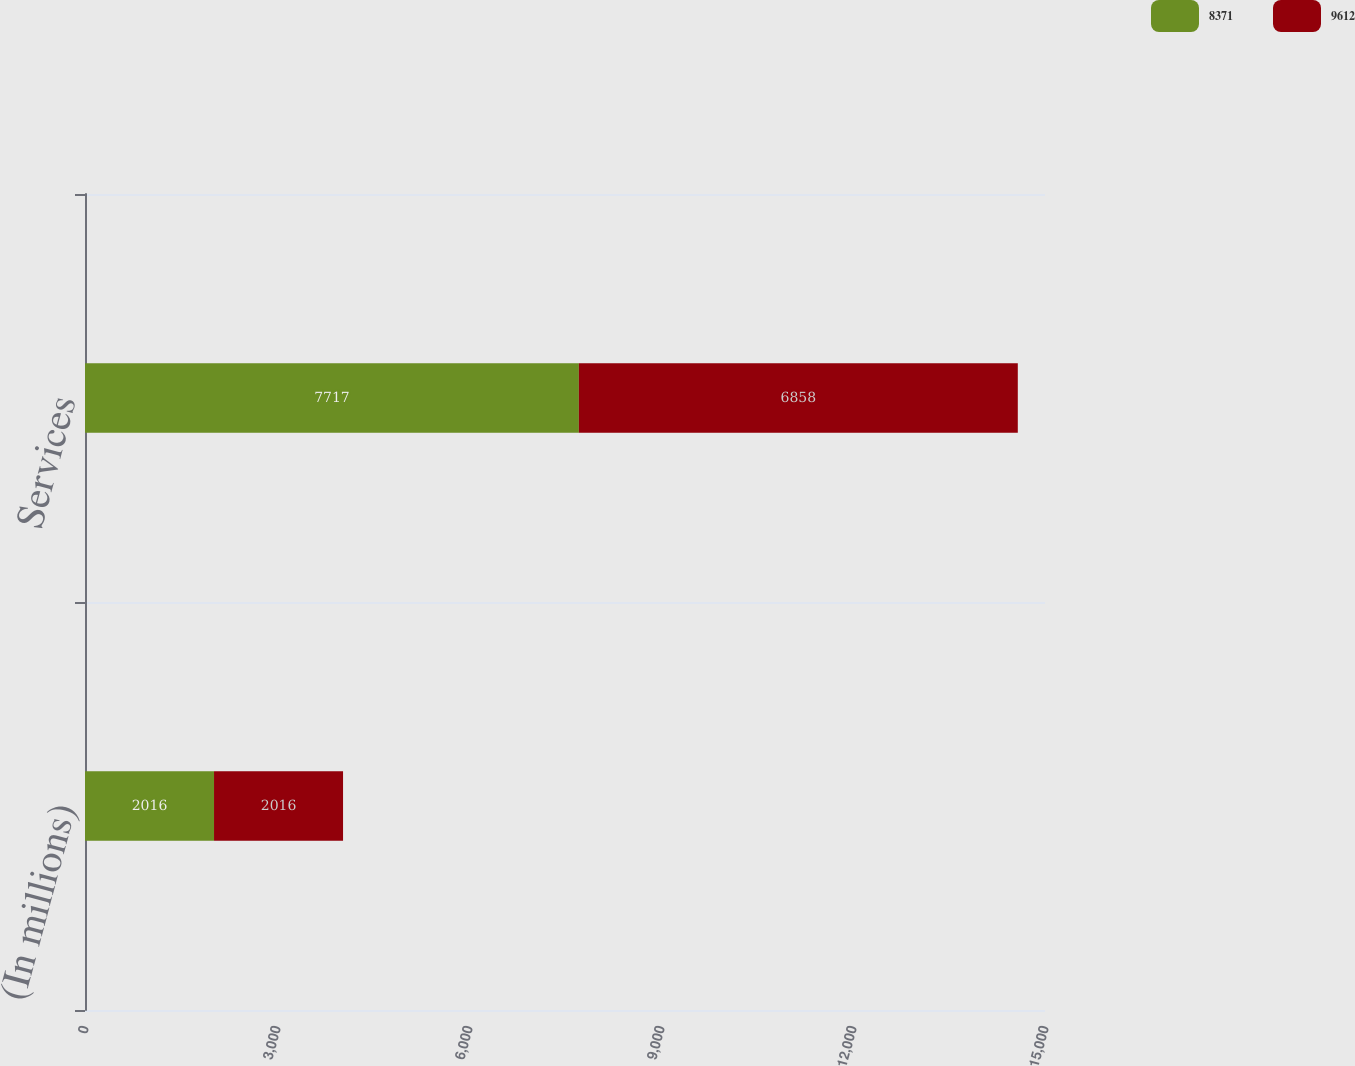<chart> <loc_0><loc_0><loc_500><loc_500><stacked_bar_chart><ecel><fcel>(In millions)<fcel>Services<nl><fcel>8371<fcel>2016<fcel>7717<nl><fcel>9612<fcel>2016<fcel>6858<nl></chart> 